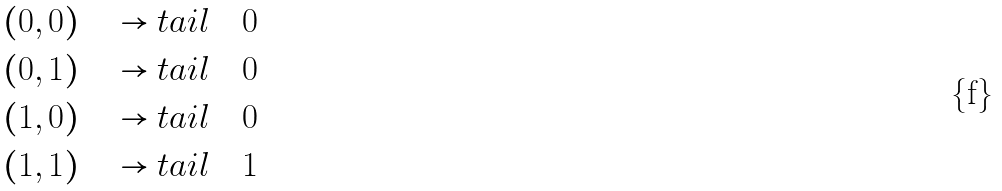<formula> <loc_0><loc_0><loc_500><loc_500>( 0 , 0 ) \quad & \rightarrow t a i l \quad 0 \\ ( 0 , 1 ) \quad & \rightarrow t a i l \quad 0 \\ ( 1 , 0 ) \quad & \rightarrow t a i l \quad 0 \\ ( 1 , 1 ) \quad & \rightarrow t a i l \quad 1</formula> 